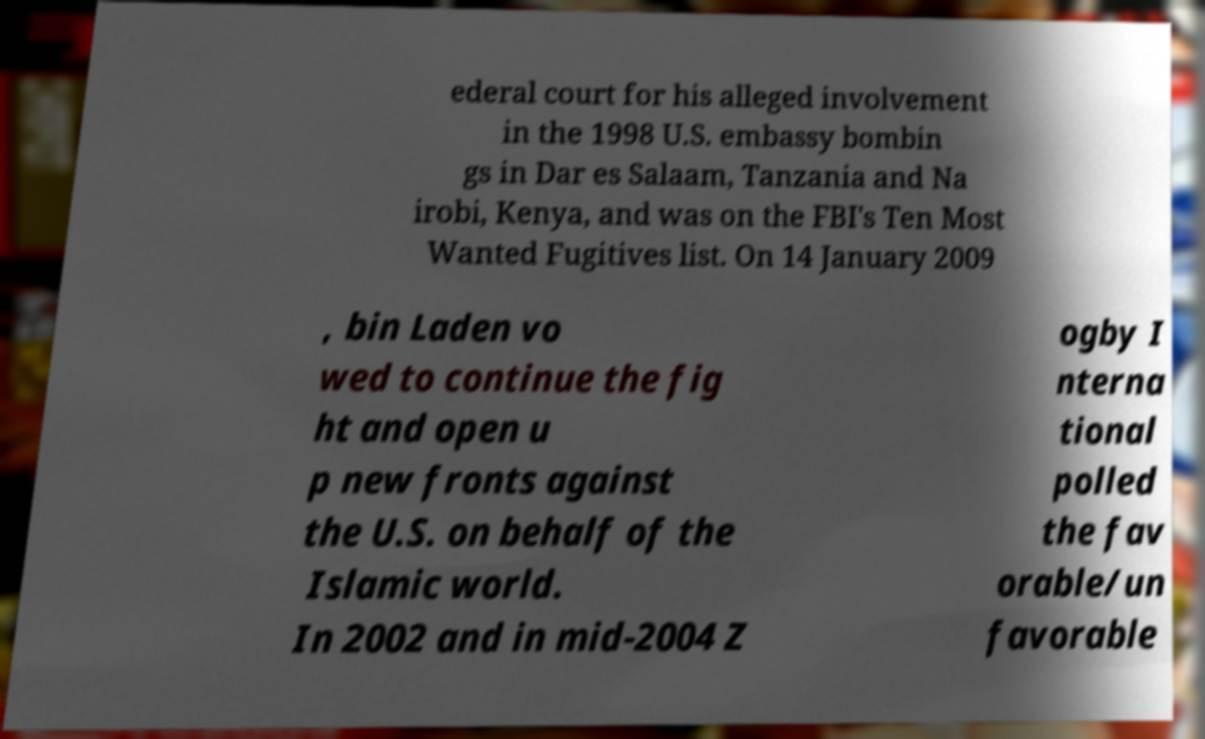Please identify and transcribe the text found in this image. ederal court for his alleged involvement in the 1998 U.S. embassy bombin gs in Dar es Salaam, Tanzania and Na irobi, Kenya, and was on the FBI's Ten Most Wanted Fugitives list. On 14 January 2009 , bin Laden vo wed to continue the fig ht and open u p new fronts against the U.S. on behalf of the Islamic world. In 2002 and in mid-2004 Z ogby I nterna tional polled the fav orable/un favorable 